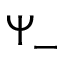<formula> <loc_0><loc_0><loc_500><loc_500>\Psi _ { - }</formula> 